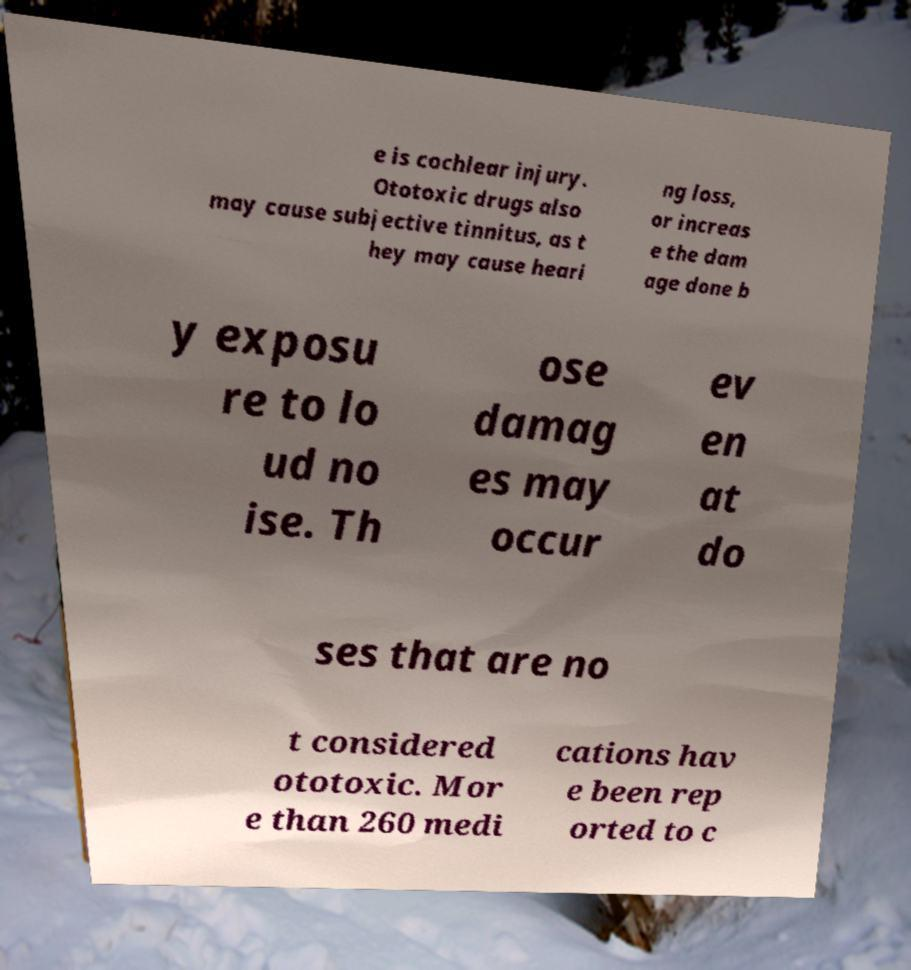What messages or text are displayed in this image? I need them in a readable, typed format. e is cochlear injury. Ototoxic drugs also may cause subjective tinnitus, as t hey may cause heari ng loss, or increas e the dam age done b y exposu re to lo ud no ise. Th ose damag es may occur ev en at do ses that are no t considered ototoxic. Mor e than 260 medi cations hav e been rep orted to c 